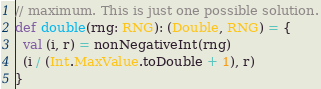Convert code to text. <code><loc_0><loc_0><loc_500><loc_500><_Scala_>// maximum. This is just one possible solution.
def double(rng: RNG): (Double, RNG) = {
  val (i, r) = nonNegativeInt(rng)
  (i / (Int.MaxValue.toDouble + 1), r)
}</code> 